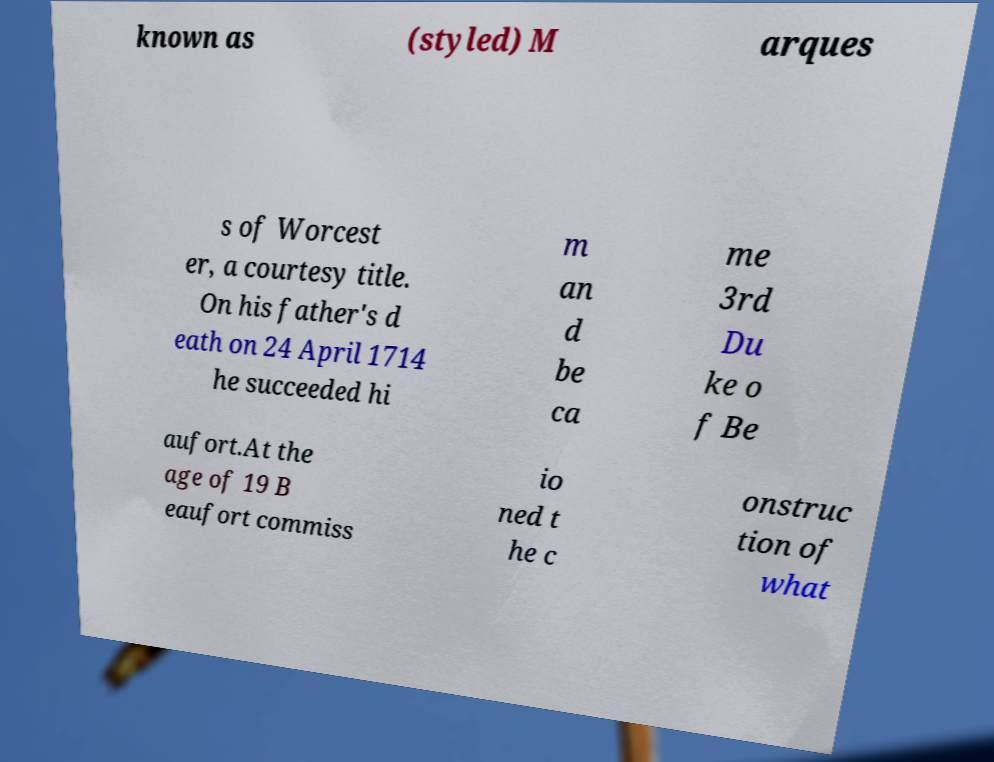I need the written content from this picture converted into text. Can you do that? known as (styled) M arques s of Worcest er, a courtesy title. On his father's d eath on 24 April 1714 he succeeded hi m an d be ca me 3rd Du ke o f Be aufort.At the age of 19 B eaufort commiss io ned t he c onstruc tion of what 